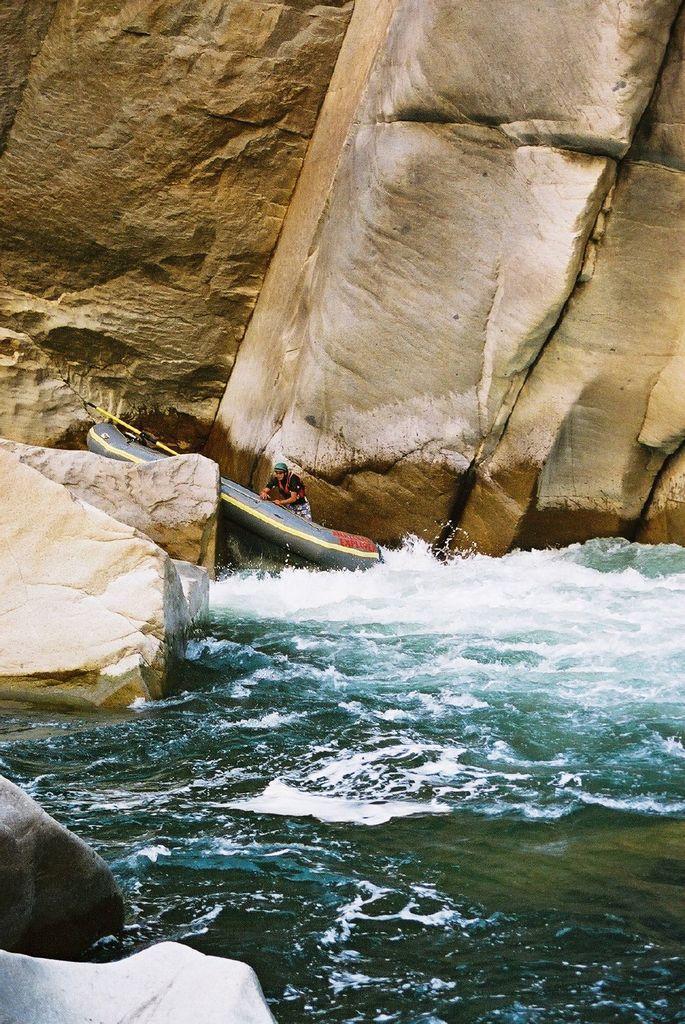Could you give a brief overview of what you see in this image? In this picture there is water at the bottom side of the image and there are rocks at the bottom side of the image, there are other rocks on the left side of the image and there is a boat and a man in the center of the image. 